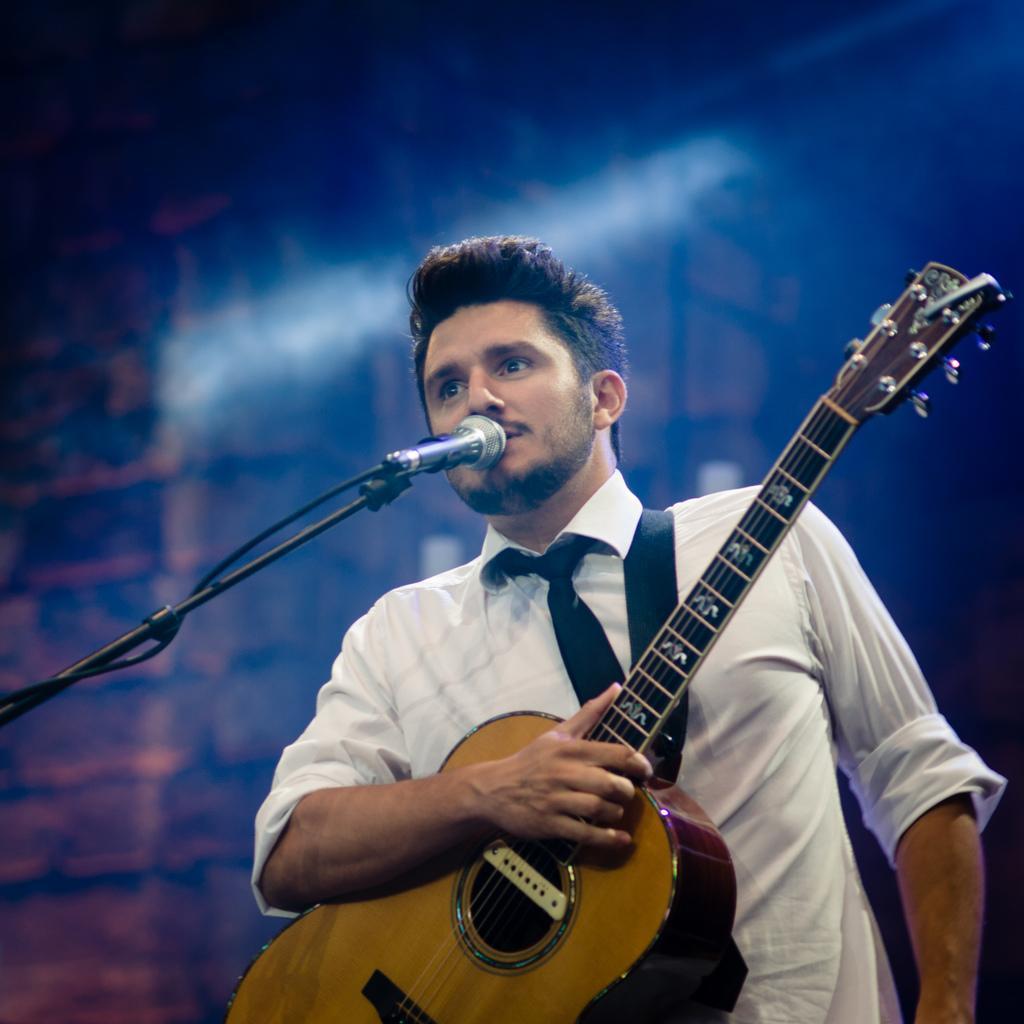How would you summarize this image in a sentence or two? In this image I can see a man wearing white color shirt and holding a guitar in his right hand. In front of this person there is a mike stand. 